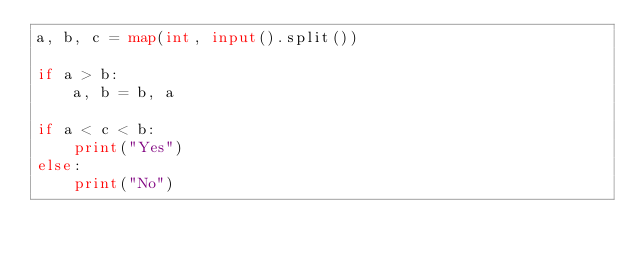<code> <loc_0><loc_0><loc_500><loc_500><_Python_>a, b, c = map(int, input().split())

if a > b:
	a, b = b, a

if a < c < b:
	print("Yes")
else:
	print("No")</code> 